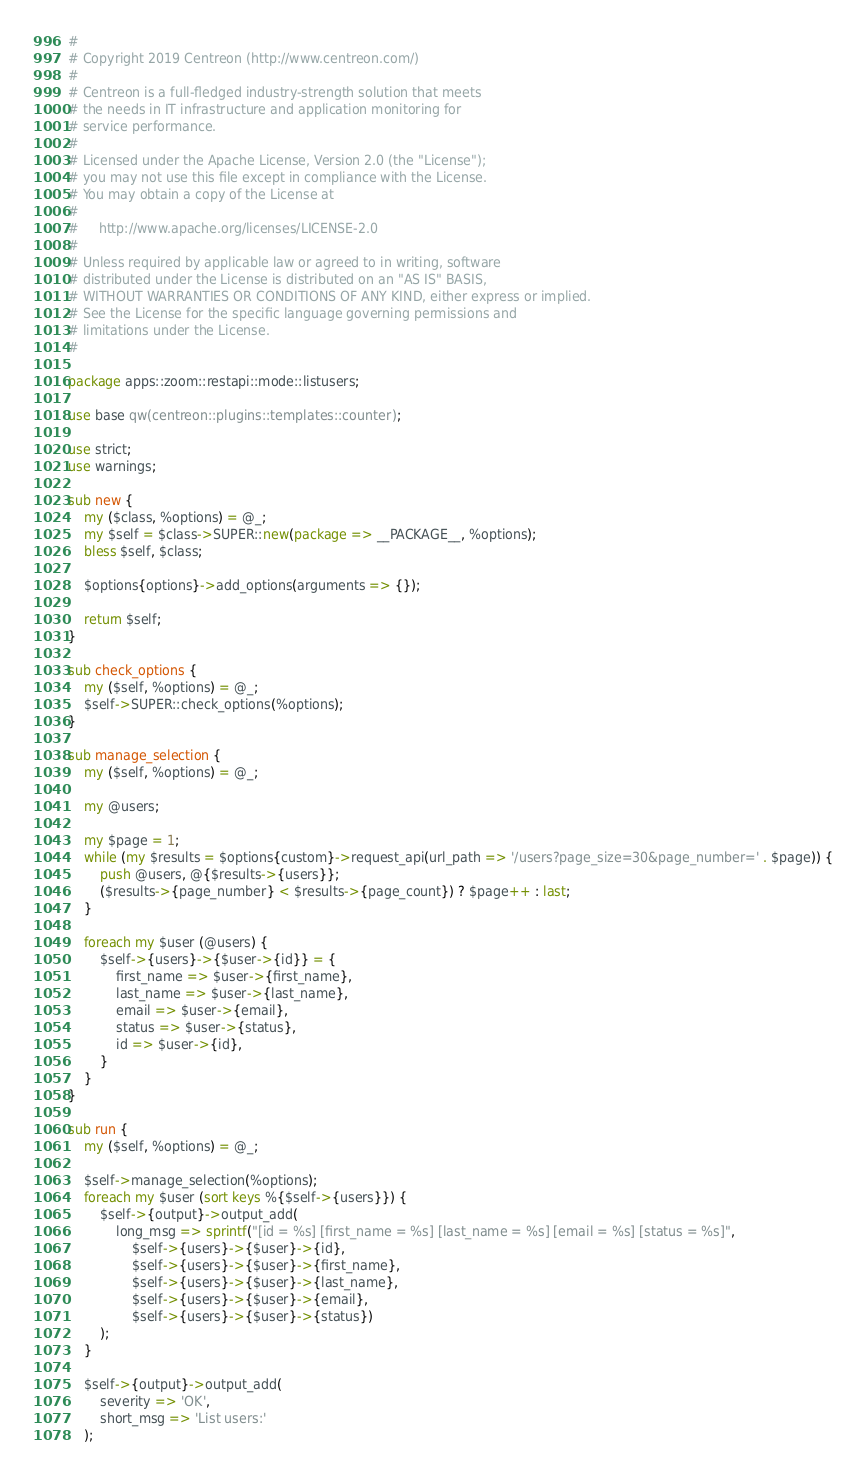Convert code to text. <code><loc_0><loc_0><loc_500><loc_500><_Perl_>#
# Copyright 2019 Centreon (http://www.centreon.com/)
#
# Centreon is a full-fledged industry-strength solution that meets
# the needs in IT infrastructure and application monitoring for
# service performance.
#
# Licensed under the Apache License, Version 2.0 (the "License");
# you may not use this file except in compliance with the License.
# You may obtain a copy of the License at
#
#     http://www.apache.org/licenses/LICENSE-2.0
#
# Unless required by applicable law or agreed to in writing, software
# distributed under the License is distributed on an "AS IS" BASIS,
# WITHOUT WARRANTIES OR CONDITIONS OF ANY KIND, either express or implied.
# See the License for the specific language governing permissions and
# limitations under the License.
#

package apps::zoom::restapi::mode::listusers;

use base qw(centreon::plugins::templates::counter);

use strict;
use warnings;

sub new {
    my ($class, %options) = @_;
    my $self = $class->SUPER::new(package => __PACKAGE__, %options);
    bless $self, $class;
    
    $options{options}->add_options(arguments => {});
   
    return $self;
}

sub check_options {
    my ($self, %options) = @_;
    $self->SUPER::check_options(%options);
}

sub manage_selection {
    my ($self, %options) = @_;

    my @users;

    my $page = 1;
    while (my $results = $options{custom}->request_api(url_path => '/users?page_size=30&page_number=' . $page)) {
        push @users, @{$results->{users}};
        ($results->{page_number} < $results->{page_count}) ? $page++ : last;
    }
    
    foreach my $user (@users) {
        $self->{users}->{$user->{id}} = {
            first_name => $user->{first_name},
            last_name => $user->{last_name},
            email => $user->{email},
            status => $user->{status},
            id => $user->{id},
        }            
    }
}

sub run {
    my ($self, %options) = @_;
  
    $self->manage_selection(%options);
    foreach my $user (sort keys %{$self->{users}}) { 
        $self->{output}->output_add(
            long_msg => sprintf("[id = %s] [first_name = %s] [last_name = %s] [email = %s] [status = %s]",
                $self->{users}->{$user}->{id},
                $self->{users}->{$user}->{first_name},
                $self->{users}->{$user}->{last_name},
                $self->{users}->{$user}->{email},
                $self->{users}->{$user}->{status})
        );
    }
    
    $self->{output}->output_add(
        severity => 'OK',
        short_msg => 'List users:'
    );</code> 